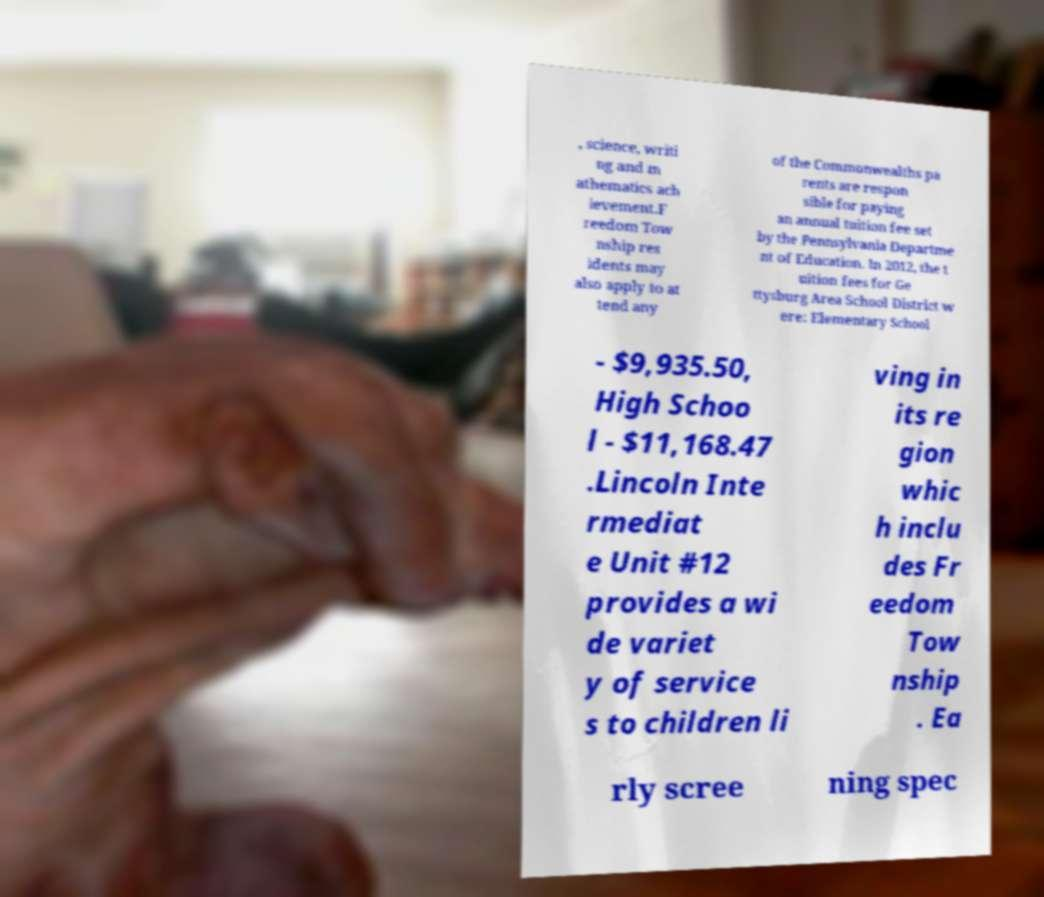For documentation purposes, I need the text within this image transcribed. Could you provide that? , science, writi ng and m athematics ach ievement.F reedom Tow nship res idents may also apply to at tend any of the Commonwealths pa rents are respon sible for paying an annual tuition fee set by the Pennsylvania Departme nt of Education. In 2012, the t uition fees for Ge ttysburg Area School District w ere: Elementary School - $9,935.50, High Schoo l - $11,168.47 .Lincoln Inte rmediat e Unit #12 provides a wi de variet y of service s to children li ving in its re gion whic h inclu des Fr eedom Tow nship . Ea rly scree ning spec 